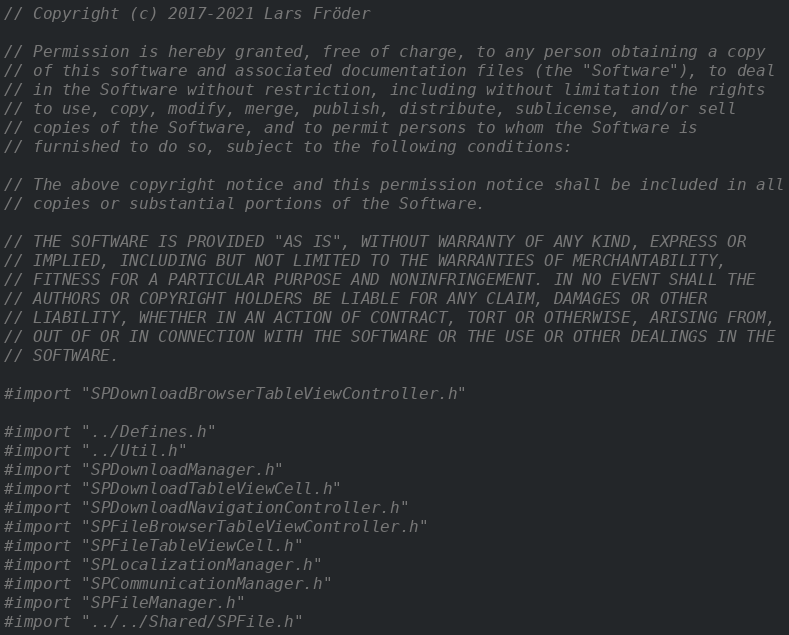<code> <loc_0><loc_0><loc_500><loc_500><_ObjectiveC_>// Copyright (c) 2017-2021 Lars Fröder

// Permission is hereby granted, free of charge, to any person obtaining a copy
// of this software and associated documentation files (the "Software"), to deal
// in the Software without restriction, including without limitation the rights
// to use, copy, modify, merge, publish, distribute, sublicense, and/or sell
// copies of the Software, and to permit persons to whom the Software is
// furnished to do so, subject to the following conditions:

// The above copyright notice and this permission notice shall be included in all
// copies or substantial portions of the Software.

// THE SOFTWARE IS PROVIDED "AS IS", WITHOUT WARRANTY OF ANY KIND, EXPRESS OR
// IMPLIED, INCLUDING BUT NOT LIMITED TO THE WARRANTIES OF MERCHANTABILITY,
// FITNESS FOR A PARTICULAR PURPOSE AND NONINFRINGEMENT. IN NO EVENT SHALL THE
// AUTHORS OR COPYRIGHT HOLDERS BE LIABLE FOR ANY CLAIM, DAMAGES OR OTHER
// LIABILITY, WHETHER IN AN ACTION OF CONTRACT, TORT OR OTHERWISE, ARISING FROM,
// OUT OF OR IN CONNECTION WITH THE SOFTWARE OR THE USE OR OTHER DEALINGS IN THE
// SOFTWARE.

#import "SPDownloadBrowserTableViewController.h"

#import "../Defines.h"
#import "../Util.h"
#import "SPDownloadManager.h"
#import "SPDownloadTableViewCell.h"
#import "SPDownloadNavigationController.h"
#import "SPFileBrowserTableViewController.h"
#import "SPFileTableViewCell.h"
#import "SPLocalizationManager.h"
#import "SPCommunicationManager.h"
#import "SPFileManager.h"
#import "../../Shared/SPFile.h"
</code> 